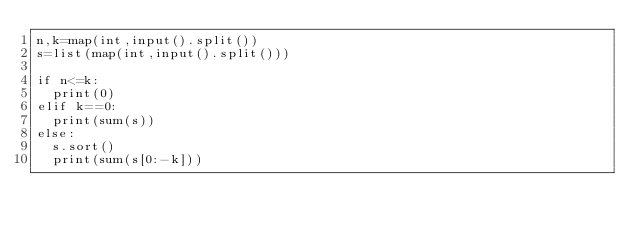Convert code to text. <code><loc_0><loc_0><loc_500><loc_500><_Python_>n,k=map(int,input().split())
s=list(map(int,input().split()))

if n<=k:
  print(0)
elif k==0:
  print(sum(s))
else:
  s.sort()
  print(sum(s[0:-k]))
</code> 